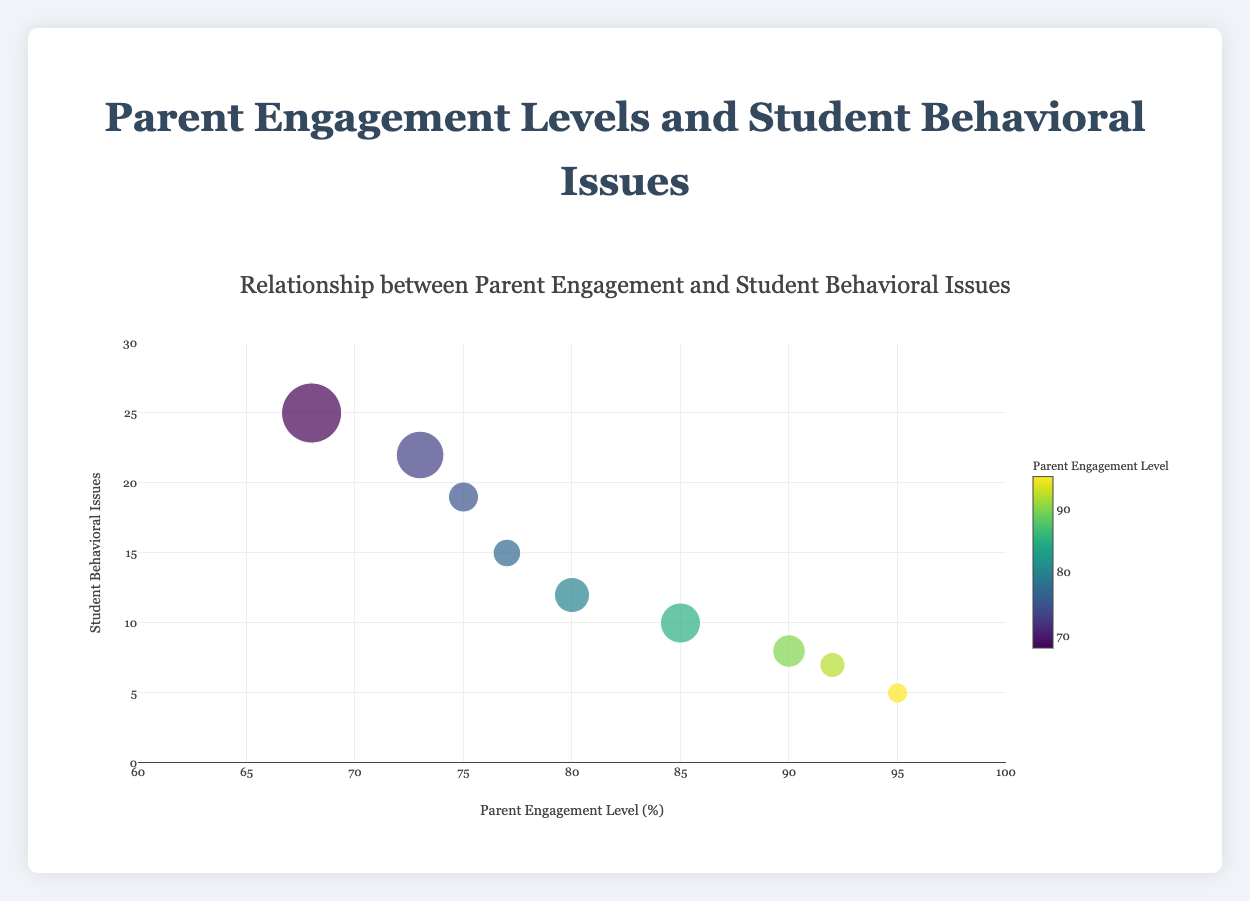What is the title of the chart? The title of the chart is present at the top and it provides an overview of what the chart represents. From the detailed description given, we know that the title is "Relationship between Parent Engagement and Student Behavioral Issues".
Answer: Relationship between Parent Engagement and Student Behavioral Issues Which school has the highest parent engagement level? To determine this, look at the x-axis which represents parent engagement levels and identify the data point with the highest value. According to the data, Oakridge Elementary has the highest parent engagement level at 95.
Answer: Oakridge Elementary What are the x-axis and y-axis labels? The x-axis label indicates what is being measured along the horizontal plane, and the y-axis label indicates what is being measured along the vertical plane. From the description, the x-axis is labeled "Parent Engagement Level (%)" and the y-axis is labeled "Student Behavioral Issues".
Answer: Parent Engagement Level (%), Student Behavioral Issues How many schools have a parent engagement level above 80%? To answer this, count the number of data points (bubbles) on the chart where the x-value (parent engagement level) is greater than 80. Based on the data, Greenwood High, Riverside Elementary, Springfield Junior High, and Oakridge Elementary have parent engagement levels above 80.
Answer: 4 Which school has the lowest number of student behavioral issues? Look at the y-axis values which represent student behavioral issues and find the data point with the lowest value. Oakridge Elementary has the lowest number of student behavioral issues with a value of 5.
Answer: Oakridge Elementary Compare the parent engagement levels of Greenwood High and Maplewood High School. Locate the data points for both Greenwood High and Maplewood High School on the x-axis. Greenwood High has a parent engagement level of 85, whereas Maplewood High School has a parent engagement level of 68. Therefore, Greenwood High has a higher parent engagement level compared to Maplewood High School.
Answer: Greenwood High has a higher parent engagement level What is the relationship between parent engagement levels and student behavioral issues according to the chart? Generally observe the trend of the data points. As the parent engagement level increases (move right along the x-axis), the number of student behavioral issues tends to decrease (move down along the y-axis). This indicates an inverse relationship.
Answer: Inverse relationship Identify the school with both high parent engagement and low behavioral issues. Look for a data point that is positioned towards the upper right on the x-axis and lower left on the y-axis, meaning high parent engagement and low behavioral issues. Riverside Elementary has a parent engagement level of 92 and student behavioral issues of 7, fitting this criteria.
Answer: Riverside Elementary What is the total number of students in all schools combined? Sum the number of students from each school: 800 + 500 + 600 + 1200 + 700 + 650 + 950 + 400 + 550. This totals to 6350 students.
Answer: 6350 Which school has the largest bubble size on the chart? Bubble size is determined by the number of students. The school with the largest number of students will have the largest bubble. Maplewood High School has 1200 students, thus its bubble is the largest.
Answer: Maplewood High School 